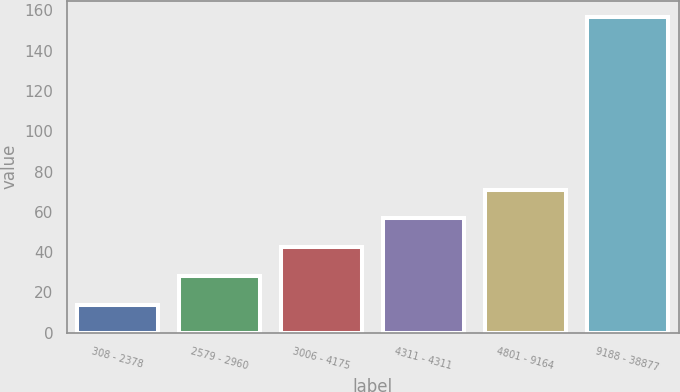Convert chart to OTSL. <chart><loc_0><loc_0><loc_500><loc_500><bar_chart><fcel>308 - 2378<fcel>2579 - 2960<fcel>3006 - 4175<fcel>4311 - 4311<fcel>4801 - 9164<fcel>9188 - 38877<nl><fcel>13.79<fcel>28.1<fcel>42.41<fcel>56.72<fcel>71.03<fcel>156.93<nl></chart> 